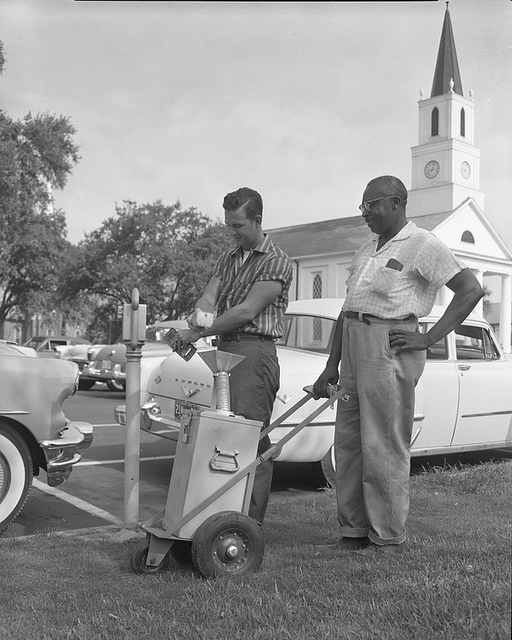<image>What is the type of material used for the crafts? I don't know what type of material is used for the crafts. It could be chalk, metal, powder, seed dispenser, or cloth. What is the type of material used for the crafts? I don't know the type of material used for the crafts. It is not clear from the given answers. 